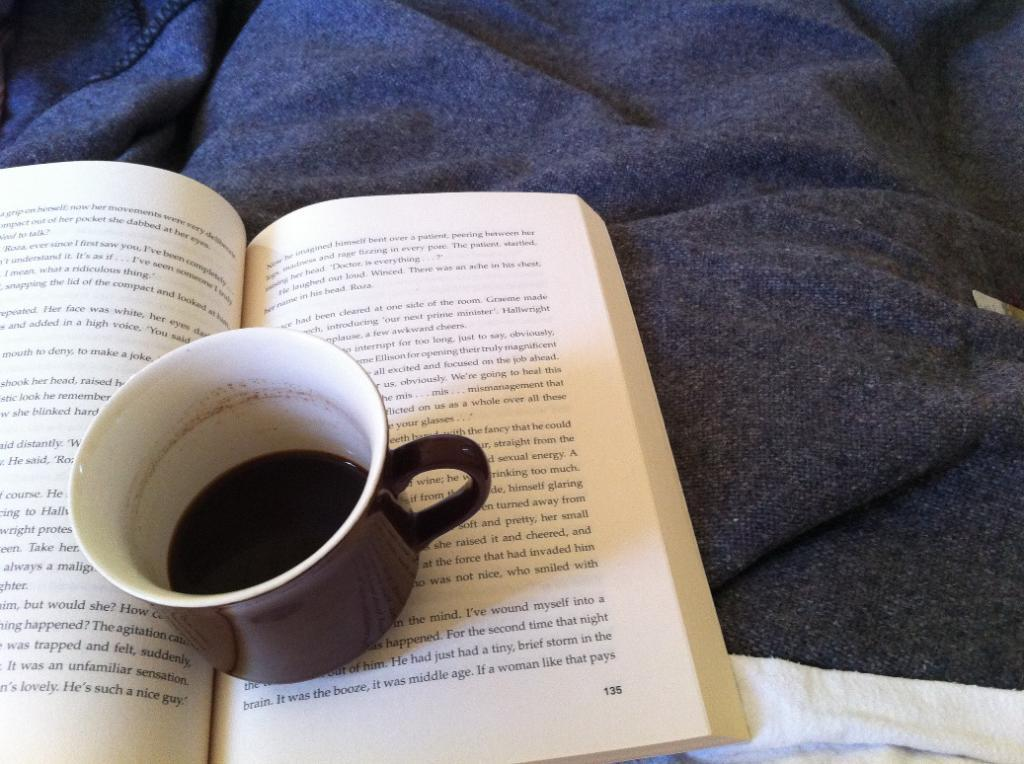What is the main object in the image? There is a book in the image. Where is the book located? The book is on a bed sheet. What else can be seen on the book? There is a cup containing a drink on the book. How many people are attending the party in the image? There is no party present in the image, so it is not possible to determine the number of attendees. 